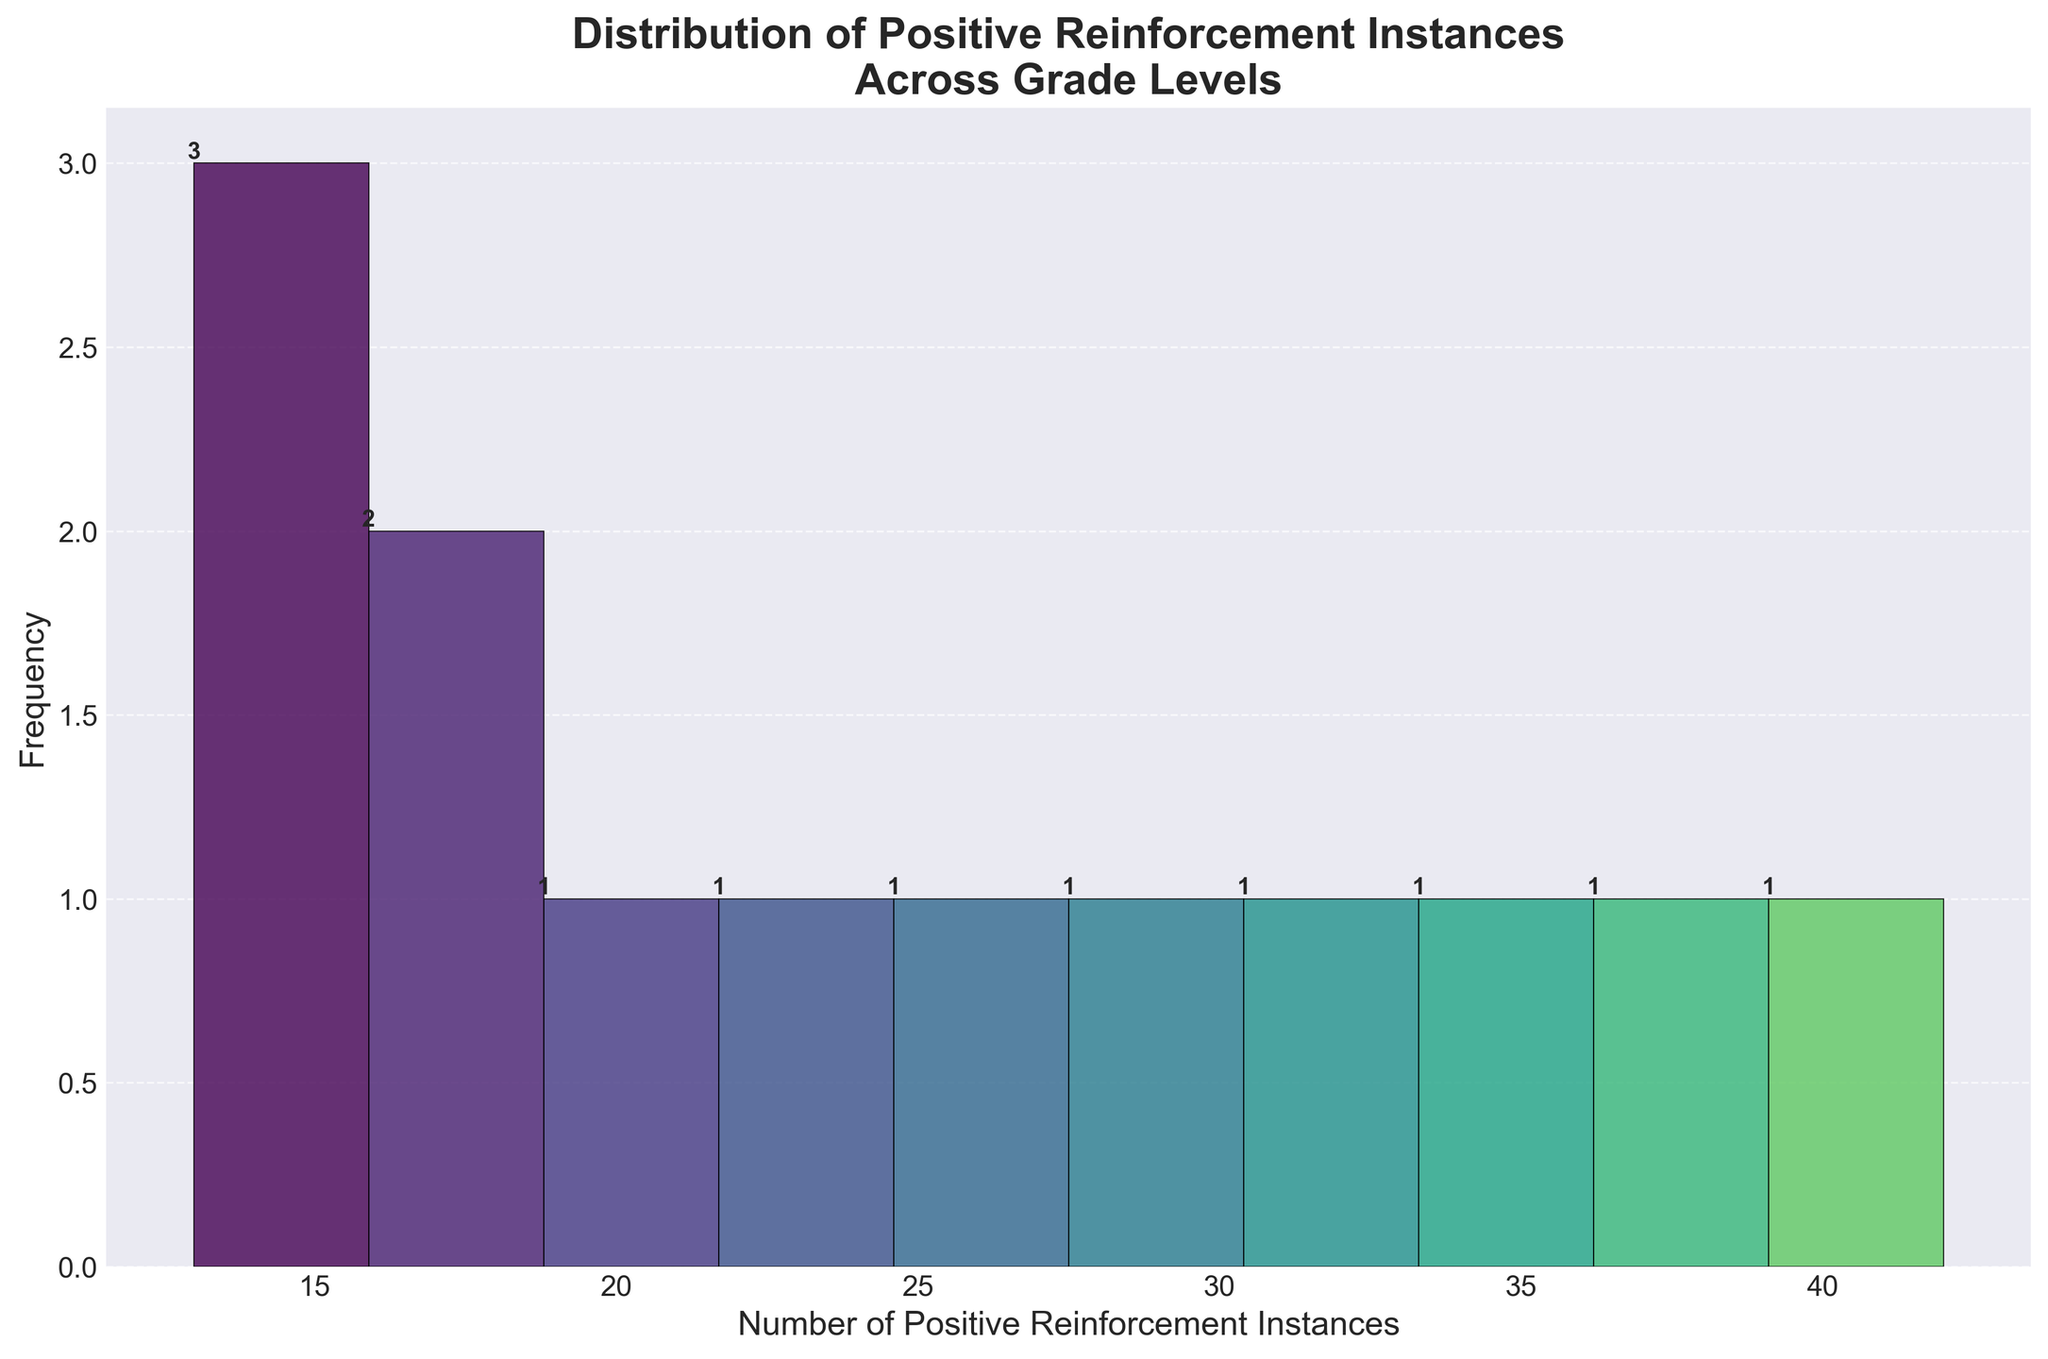How many bins are used in the histogram? The histogram has bins that group the data for visualization. By counting the number of groups along the x-axis, we can determine the number of bins used.
Answer: 10 What is the title of the histogram? The title is displayed at the top of the figure.
Answer: Distribution of Positive Reinforcement Instances Across Grade Levels What does the x-axis represent? The label of the x-axis indicates what is being measured along that axis.
Answer: Number of Positive Reinforcement Instances What does the y-axis represent? The label of the y-axis indicates what is being measured along that axis.
Answer: Frequency Which bin has the highest frequency of positive reinforcement instances? The highest bar on the histogram represents the bin with the highest frequency. We can visually inspect the height of the bars to identify the tallest one.
Answer: The first bin What is the total number of positive reinforcement instances between 15 to 25? We need to add the frequencies of all bins that fall within the range of 15 to 25 on the x-axis. By referring to the heights of the bars in this range, we can calculate the sum.
Answer: 43 How many grade levels recorded 15 or fewer positive reinforcement instances? Identify the bins corresponding to 15 or fewer instances and count the totals.
Answer: 4 Which grade level had the fewest number of positive reinforcement instances? We need to find the smallest value on the x-axis and then identify the corresponding grade level from the dataset.
Answer: 12th Grade How does the frequency of positive reinforcement instances decrease as the grade levels increase? By analyzing the histogram bars from left to right, we can observe the trend in the frequency decrease.
Answer: The frequency generally declines as the grade levels increase 